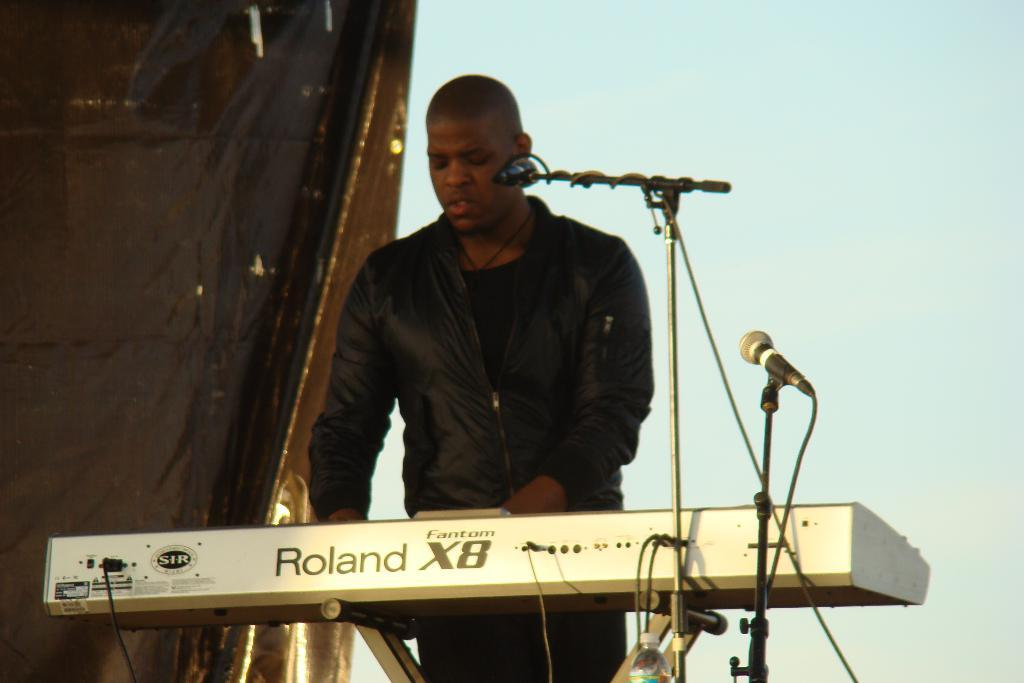What is the main subject of the image? There is a man in the image. What is the man wearing? The man is wearing a black jacket. What is the man doing in the image? The man is standing and playing a piano. What is in front of the man's mouth? There is a microphone in front of the man's mouth. What color is the cloth in the background? There is a black color cloth in the background. Can you see any corn growing in the background of the image? There is no corn visible in the image; the background features a black color cloth. 